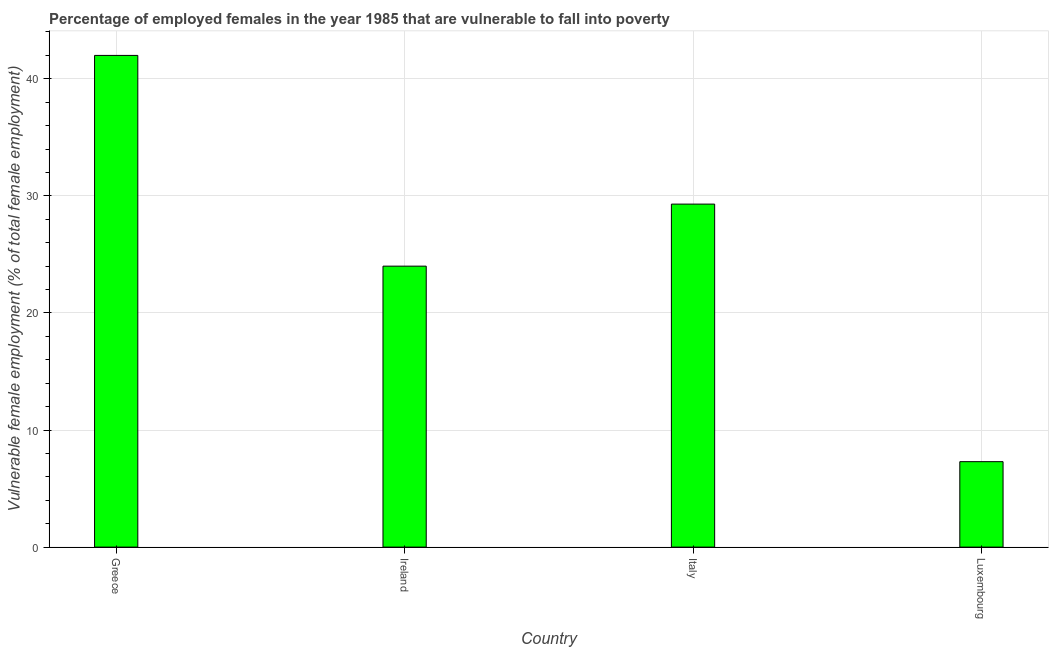Does the graph contain any zero values?
Give a very brief answer. No. Does the graph contain grids?
Your answer should be very brief. Yes. What is the title of the graph?
Ensure brevity in your answer.  Percentage of employed females in the year 1985 that are vulnerable to fall into poverty. What is the label or title of the Y-axis?
Make the answer very short. Vulnerable female employment (% of total female employment). What is the percentage of employed females who are vulnerable to fall into poverty in Greece?
Your answer should be compact. 42. Across all countries, what is the minimum percentage of employed females who are vulnerable to fall into poverty?
Offer a very short reply. 7.3. In which country was the percentage of employed females who are vulnerable to fall into poverty maximum?
Provide a short and direct response. Greece. In which country was the percentage of employed females who are vulnerable to fall into poverty minimum?
Provide a short and direct response. Luxembourg. What is the sum of the percentage of employed females who are vulnerable to fall into poverty?
Your answer should be compact. 102.6. What is the difference between the percentage of employed females who are vulnerable to fall into poverty in Greece and Ireland?
Ensure brevity in your answer.  18. What is the average percentage of employed females who are vulnerable to fall into poverty per country?
Give a very brief answer. 25.65. What is the median percentage of employed females who are vulnerable to fall into poverty?
Provide a succinct answer. 26.65. What is the ratio of the percentage of employed females who are vulnerable to fall into poverty in Greece to that in Italy?
Make the answer very short. 1.43. Is the difference between the percentage of employed females who are vulnerable to fall into poverty in Greece and Italy greater than the difference between any two countries?
Ensure brevity in your answer.  No. What is the difference between the highest and the second highest percentage of employed females who are vulnerable to fall into poverty?
Offer a very short reply. 12.7. Is the sum of the percentage of employed females who are vulnerable to fall into poverty in Italy and Luxembourg greater than the maximum percentage of employed females who are vulnerable to fall into poverty across all countries?
Provide a succinct answer. No. What is the difference between the highest and the lowest percentage of employed females who are vulnerable to fall into poverty?
Offer a terse response. 34.7. How many countries are there in the graph?
Offer a very short reply. 4. Are the values on the major ticks of Y-axis written in scientific E-notation?
Offer a terse response. No. What is the Vulnerable female employment (% of total female employment) in Greece?
Provide a short and direct response. 42. What is the Vulnerable female employment (% of total female employment) of Ireland?
Provide a short and direct response. 24. What is the Vulnerable female employment (% of total female employment) in Italy?
Provide a short and direct response. 29.3. What is the Vulnerable female employment (% of total female employment) of Luxembourg?
Offer a very short reply. 7.3. What is the difference between the Vulnerable female employment (% of total female employment) in Greece and Italy?
Provide a short and direct response. 12.7. What is the difference between the Vulnerable female employment (% of total female employment) in Greece and Luxembourg?
Keep it short and to the point. 34.7. What is the difference between the Vulnerable female employment (% of total female employment) in Ireland and Luxembourg?
Offer a terse response. 16.7. What is the difference between the Vulnerable female employment (% of total female employment) in Italy and Luxembourg?
Ensure brevity in your answer.  22. What is the ratio of the Vulnerable female employment (% of total female employment) in Greece to that in Ireland?
Offer a terse response. 1.75. What is the ratio of the Vulnerable female employment (% of total female employment) in Greece to that in Italy?
Your answer should be compact. 1.43. What is the ratio of the Vulnerable female employment (% of total female employment) in Greece to that in Luxembourg?
Make the answer very short. 5.75. What is the ratio of the Vulnerable female employment (% of total female employment) in Ireland to that in Italy?
Provide a short and direct response. 0.82. What is the ratio of the Vulnerable female employment (% of total female employment) in Ireland to that in Luxembourg?
Offer a very short reply. 3.29. What is the ratio of the Vulnerable female employment (% of total female employment) in Italy to that in Luxembourg?
Offer a very short reply. 4.01. 